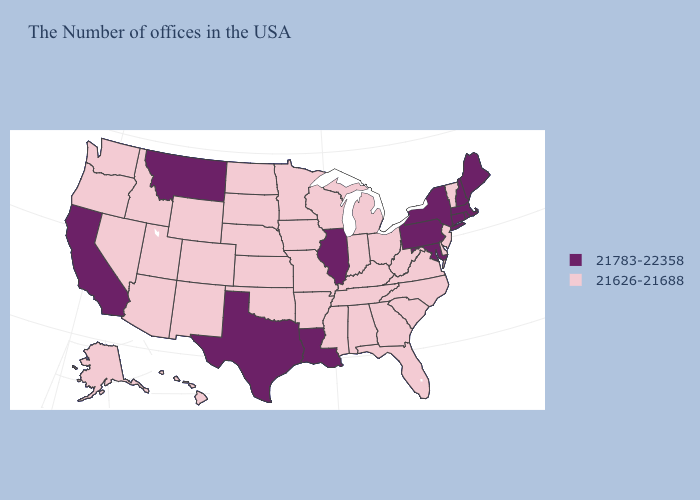Does Alabama have the lowest value in the USA?
Short answer required. Yes. What is the lowest value in the USA?
Concise answer only. 21626-21688. What is the value of Alabama?
Keep it brief. 21626-21688. Name the states that have a value in the range 21783-22358?
Quick response, please. Maine, Massachusetts, Rhode Island, New Hampshire, Connecticut, New York, Maryland, Pennsylvania, Illinois, Louisiana, Texas, Montana, California. What is the value of Arizona?
Concise answer only. 21626-21688. Which states have the highest value in the USA?
Answer briefly. Maine, Massachusetts, Rhode Island, New Hampshire, Connecticut, New York, Maryland, Pennsylvania, Illinois, Louisiana, Texas, Montana, California. Which states have the highest value in the USA?
Concise answer only. Maine, Massachusetts, Rhode Island, New Hampshire, Connecticut, New York, Maryland, Pennsylvania, Illinois, Louisiana, Texas, Montana, California. How many symbols are there in the legend?
Short answer required. 2. Does the map have missing data?
Quick response, please. No. Does Nevada have a lower value than Maryland?
Answer briefly. Yes. What is the value of Kansas?
Give a very brief answer. 21626-21688. Which states hav the highest value in the West?
Short answer required. Montana, California. Name the states that have a value in the range 21783-22358?
Short answer required. Maine, Massachusetts, Rhode Island, New Hampshire, Connecticut, New York, Maryland, Pennsylvania, Illinois, Louisiana, Texas, Montana, California. What is the value of Hawaii?
Concise answer only. 21626-21688. 